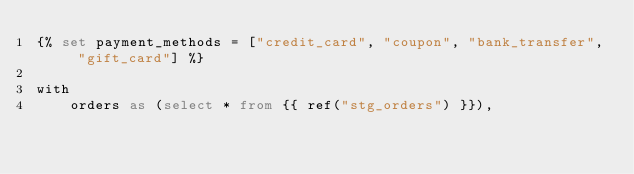<code> <loc_0><loc_0><loc_500><loc_500><_SQL_>{% set payment_methods = ["credit_card", "coupon", "bank_transfer", "gift_card"] %}

with
    orders as (select * from {{ ref("stg_orders") }}),
</code> 